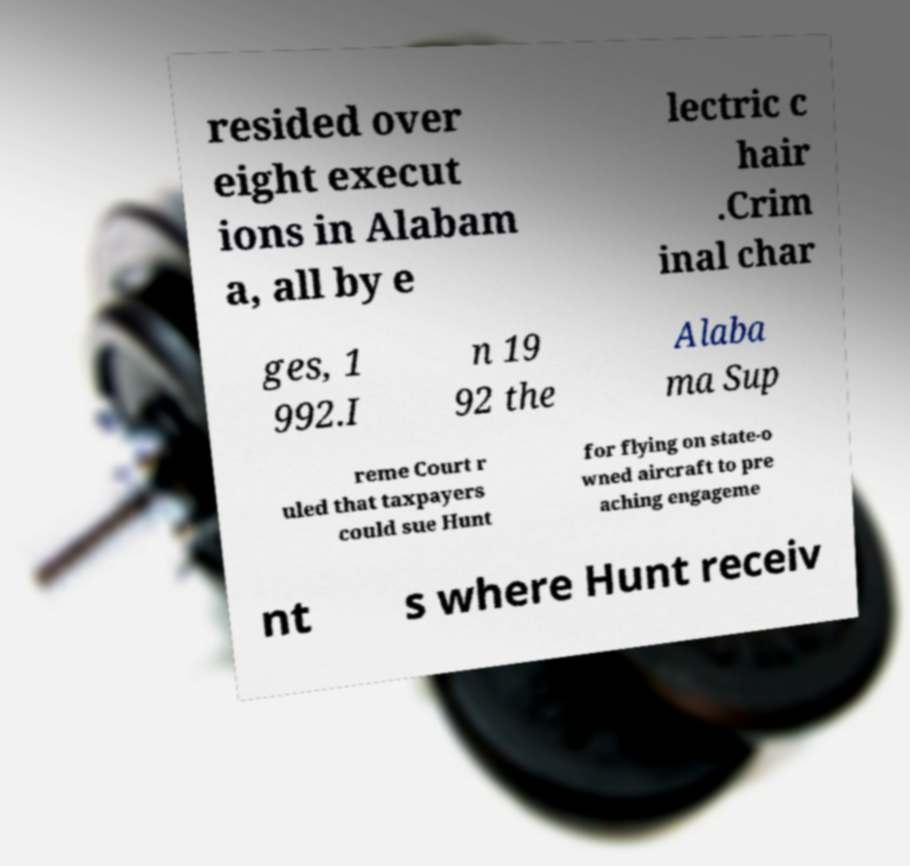Please identify and transcribe the text found in this image. resided over eight execut ions in Alabam a, all by e lectric c hair .Crim inal char ges, 1 992.I n 19 92 the Alaba ma Sup reme Court r uled that taxpayers could sue Hunt for flying on state-o wned aircraft to pre aching engageme nt s where Hunt receiv 